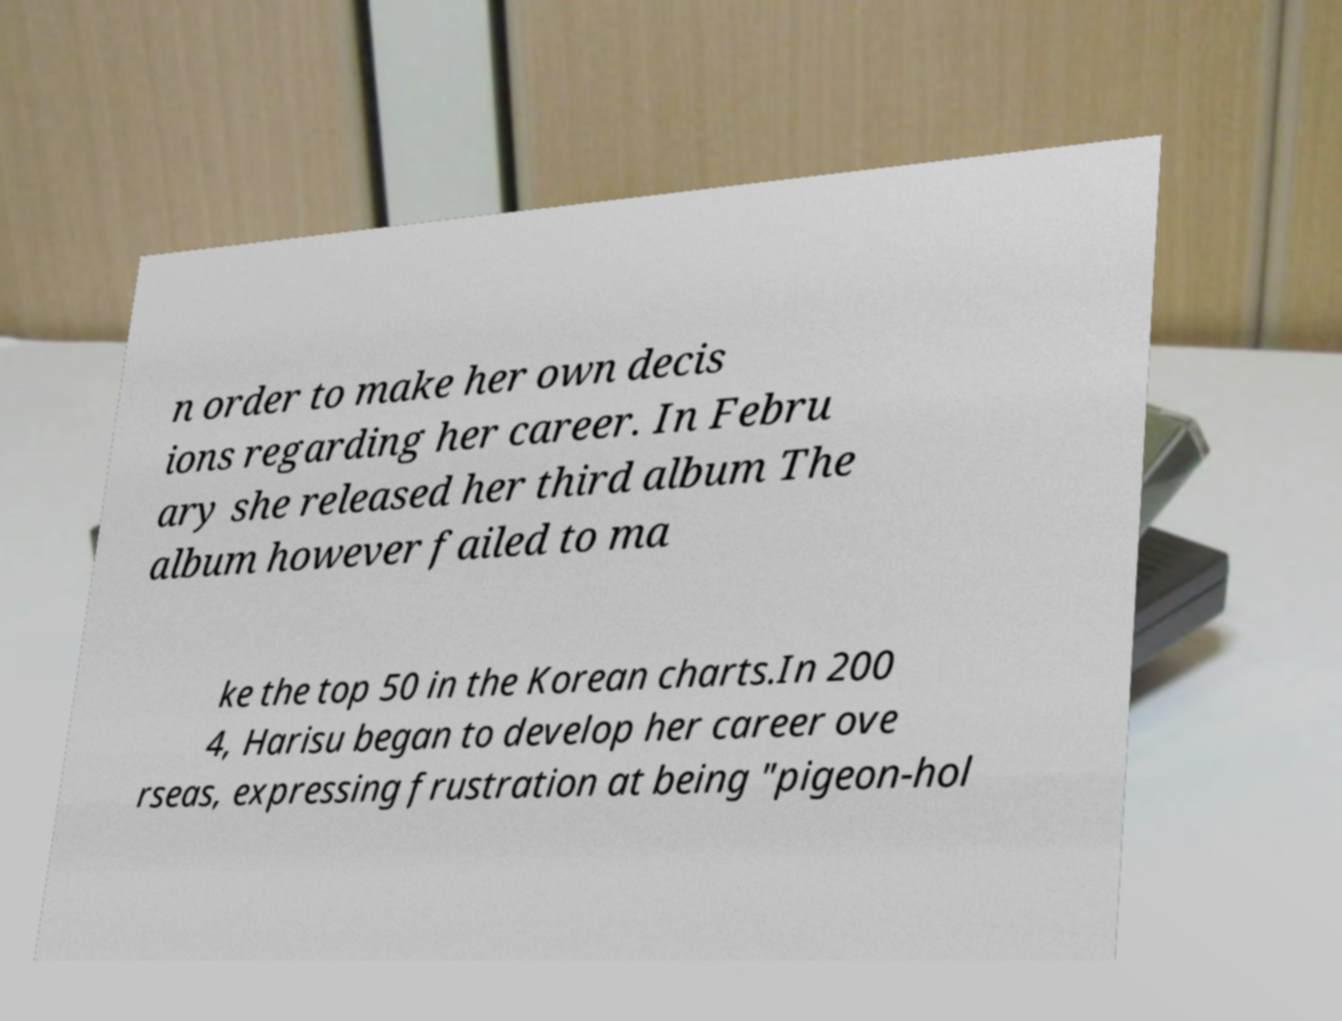There's text embedded in this image that I need extracted. Can you transcribe it verbatim? n order to make her own decis ions regarding her career. In Febru ary she released her third album The album however failed to ma ke the top 50 in the Korean charts.In 200 4, Harisu began to develop her career ove rseas, expressing frustration at being "pigeon-hol 